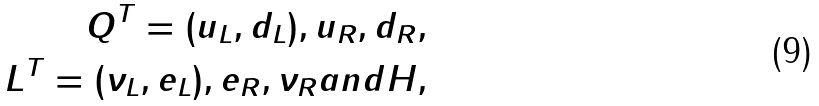<formula> <loc_0><loc_0><loc_500><loc_500>Q ^ { T } = ( u _ { L } , d _ { L } ) , u _ { R } , d _ { R } , \\ L ^ { T } = ( \nu _ { L } , e _ { L } ) , e _ { R } , \nu _ { R } a n d H ,</formula> 